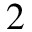Convert formula to latex. <formula><loc_0><loc_0><loc_500><loc_500>2</formula> 